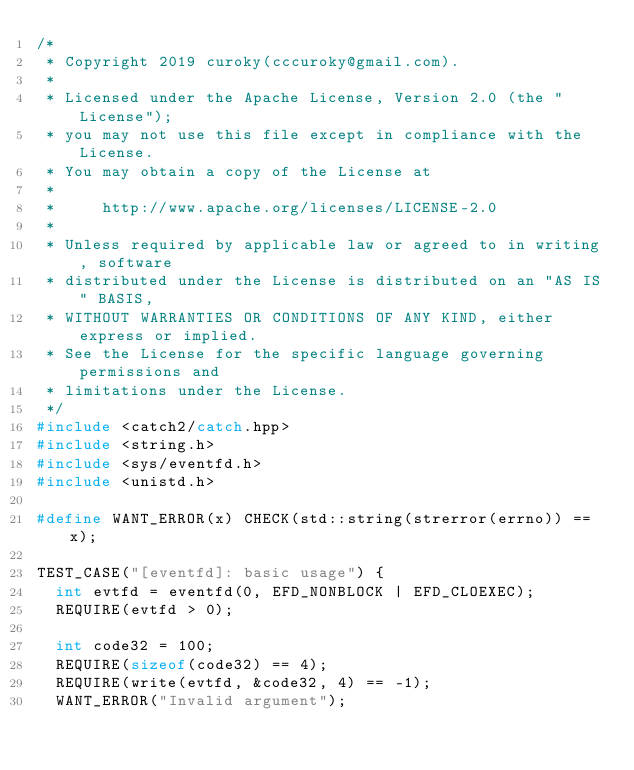<code> <loc_0><loc_0><loc_500><loc_500><_C++_>/*
 * Copyright 2019 curoky(cccuroky@gmail.com).
 *
 * Licensed under the Apache License, Version 2.0 (the "License");
 * you may not use this file except in compliance with the License.
 * You may obtain a copy of the License at
 *
 *     http://www.apache.org/licenses/LICENSE-2.0
 *
 * Unless required by applicable law or agreed to in writing, software
 * distributed under the License is distributed on an "AS IS" BASIS,
 * WITHOUT WARRANTIES OR CONDITIONS OF ANY KIND, either express or implied.
 * See the License for the specific language governing permissions and
 * limitations under the License.
 */
#include <catch2/catch.hpp>
#include <string.h>
#include <sys/eventfd.h>
#include <unistd.h>

#define WANT_ERROR(x) CHECK(std::string(strerror(errno)) == x);

TEST_CASE("[eventfd]: basic usage") {
  int evtfd = eventfd(0, EFD_NONBLOCK | EFD_CLOEXEC);
  REQUIRE(evtfd > 0);

  int code32 = 100;
  REQUIRE(sizeof(code32) == 4);
  REQUIRE(write(evtfd, &code32, 4) == -1);
  WANT_ERROR("Invalid argument");
</code> 